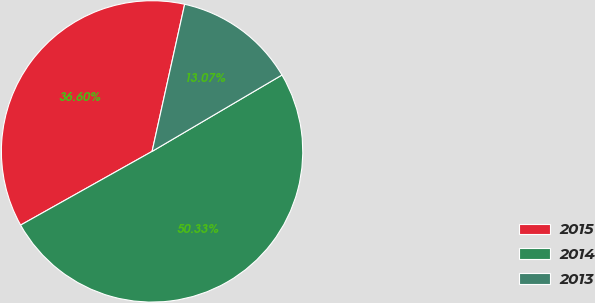Convert chart to OTSL. <chart><loc_0><loc_0><loc_500><loc_500><pie_chart><fcel>2015<fcel>2014<fcel>2013<nl><fcel>36.6%<fcel>50.33%<fcel>13.07%<nl></chart> 